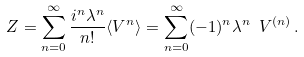Convert formula to latex. <formula><loc_0><loc_0><loc_500><loc_500>Z = \sum _ { n = 0 } ^ { \infty } \frac { i ^ { n } \lambda ^ { n } } { n ! } \langle V ^ { n } \rangle = \sum _ { n = 0 } ^ { \infty } ( - 1 ) ^ { n } \lambda ^ { n } \ V ^ { ( n ) } \, .</formula> 